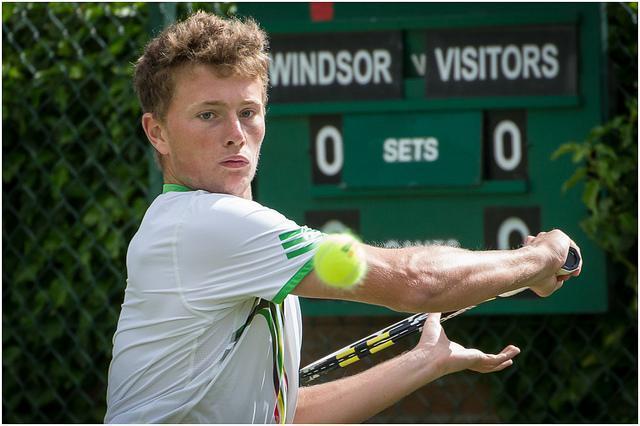Someone needs to score at least how many sets to win?
Indicate the correct response by choosing from the four available options to answer the question.
Options: Four, five, two, eight. Two. 